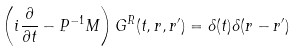<formula> <loc_0><loc_0><loc_500><loc_500>\left ( i \frac { \partial } { \partial t } - { P } ^ { - 1 } { M } \right ) { G } ^ { R } ( t , { r } , { r ^ { \prime } } ) = \delta ( t ) \delta ( { r - r ^ { \prime } } )</formula> 